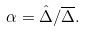<formula> <loc_0><loc_0><loc_500><loc_500>\alpha = { \hat { \Delta } } / { \overline { \Delta } } .</formula> 